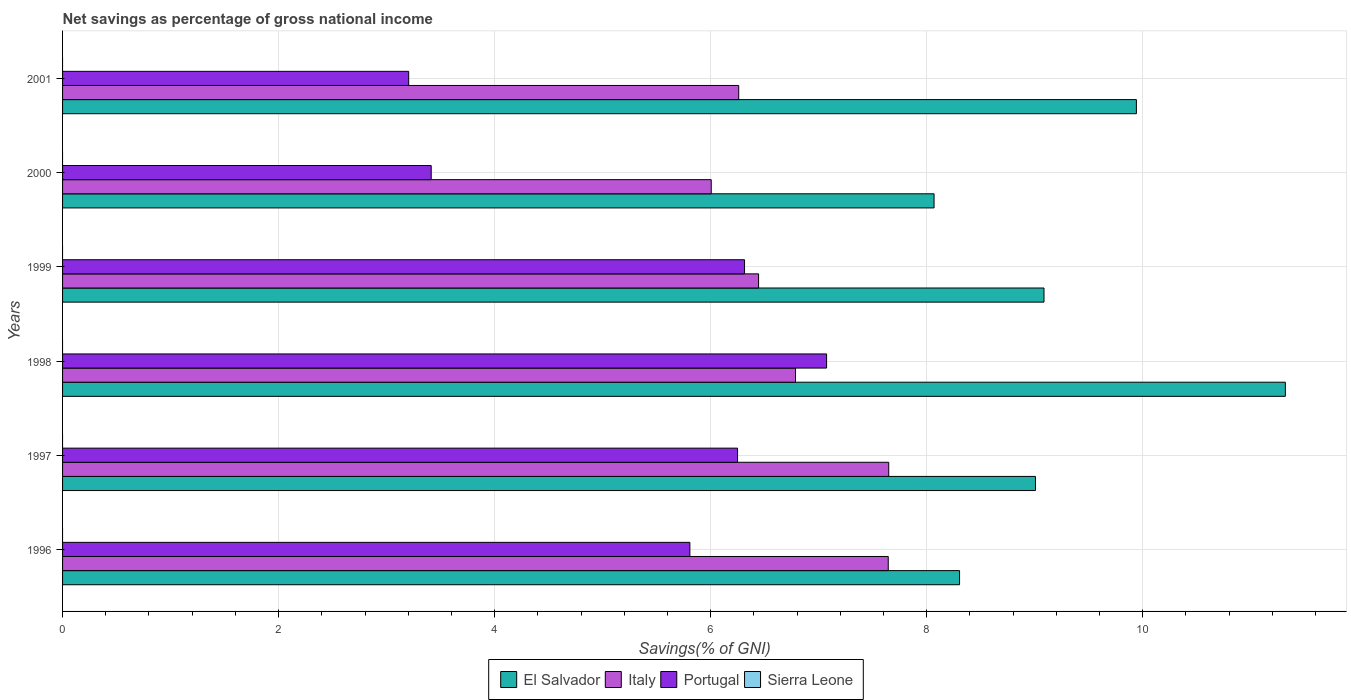How many groups of bars are there?
Offer a very short reply. 6. Are the number of bars per tick equal to the number of legend labels?
Your response must be concise. No. Are the number of bars on each tick of the Y-axis equal?
Keep it short and to the point. Yes. How many bars are there on the 3rd tick from the top?
Make the answer very short. 3. How many bars are there on the 1st tick from the bottom?
Keep it short and to the point. 3. In how many cases, is the number of bars for a given year not equal to the number of legend labels?
Offer a very short reply. 6. What is the total savings in Portugal in 1997?
Give a very brief answer. 6.25. Across all years, what is the maximum total savings in Portugal?
Ensure brevity in your answer.  7.07. Across all years, what is the minimum total savings in Italy?
Offer a terse response. 6.01. What is the total total savings in Italy in the graph?
Provide a short and direct response. 40.79. What is the difference between the total savings in El Salvador in 1997 and that in 1998?
Keep it short and to the point. -2.31. What is the difference between the total savings in Italy in 1996 and the total savings in Portugal in 2000?
Your answer should be very brief. 4.23. In the year 1996, what is the difference between the total savings in Portugal and total savings in Italy?
Your answer should be compact. -1.84. What is the ratio of the total savings in Italy in 1996 to that in 1999?
Offer a terse response. 1.19. Is the total savings in Portugal in 2000 less than that in 2001?
Keep it short and to the point. No. What is the difference between the highest and the second highest total savings in Italy?
Keep it short and to the point. 0. What is the difference between the highest and the lowest total savings in Italy?
Your answer should be compact. 1.64. Is the sum of the total savings in Portugal in 1997 and 2001 greater than the maximum total savings in Sierra Leone across all years?
Offer a terse response. Yes. Is it the case that in every year, the sum of the total savings in Italy and total savings in Portugal is greater than the sum of total savings in El Salvador and total savings in Sierra Leone?
Your response must be concise. No. Is it the case that in every year, the sum of the total savings in El Salvador and total savings in Italy is greater than the total savings in Sierra Leone?
Your answer should be compact. Yes. How many bars are there?
Your response must be concise. 18. How many years are there in the graph?
Ensure brevity in your answer.  6. What is the difference between two consecutive major ticks on the X-axis?
Provide a succinct answer. 2. How many legend labels are there?
Your answer should be very brief. 4. What is the title of the graph?
Your answer should be very brief. Net savings as percentage of gross national income. Does "Puerto Rico" appear as one of the legend labels in the graph?
Your answer should be very brief. No. What is the label or title of the X-axis?
Provide a succinct answer. Savings(% of GNI). What is the Savings(% of GNI) in El Salvador in 1996?
Your response must be concise. 8.3. What is the Savings(% of GNI) in Italy in 1996?
Your answer should be very brief. 7.64. What is the Savings(% of GNI) in Portugal in 1996?
Make the answer very short. 5.81. What is the Savings(% of GNI) of Sierra Leone in 1996?
Keep it short and to the point. 0. What is the Savings(% of GNI) of El Salvador in 1997?
Keep it short and to the point. 9.01. What is the Savings(% of GNI) in Italy in 1997?
Your answer should be compact. 7.65. What is the Savings(% of GNI) in Portugal in 1997?
Your response must be concise. 6.25. What is the Savings(% of GNI) in Sierra Leone in 1997?
Make the answer very short. 0. What is the Savings(% of GNI) of El Salvador in 1998?
Give a very brief answer. 11.32. What is the Savings(% of GNI) in Italy in 1998?
Offer a very short reply. 6.79. What is the Savings(% of GNI) in Portugal in 1998?
Give a very brief answer. 7.07. What is the Savings(% of GNI) in El Salvador in 1999?
Your answer should be very brief. 9.09. What is the Savings(% of GNI) of Italy in 1999?
Provide a short and direct response. 6.44. What is the Savings(% of GNI) of Portugal in 1999?
Your response must be concise. 6.31. What is the Savings(% of GNI) of Sierra Leone in 1999?
Your answer should be compact. 0. What is the Savings(% of GNI) of El Salvador in 2000?
Ensure brevity in your answer.  8.07. What is the Savings(% of GNI) in Italy in 2000?
Keep it short and to the point. 6.01. What is the Savings(% of GNI) of Portugal in 2000?
Your answer should be very brief. 3.41. What is the Savings(% of GNI) of Sierra Leone in 2000?
Your answer should be compact. 0. What is the Savings(% of GNI) in El Salvador in 2001?
Keep it short and to the point. 9.94. What is the Savings(% of GNI) of Italy in 2001?
Offer a terse response. 6.26. What is the Savings(% of GNI) of Portugal in 2001?
Provide a short and direct response. 3.2. What is the Savings(% of GNI) in Sierra Leone in 2001?
Make the answer very short. 0. Across all years, what is the maximum Savings(% of GNI) in El Salvador?
Ensure brevity in your answer.  11.32. Across all years, what is the maximum Savings(% of GNI) in Italy?
Your answer should be very brief. 7.65. Across all years, what is the maximum Savings(% of GNI) in Portugal?
Ensure brevity in your answer.  7.07. Across all years, what is the minimum Savings(% of GNI) in El Salvador?
Ensure brevity in your answer.  8.07. Across all years, what is the minimum Savings(% of GNI) of Italy?
Make the answer very short. 6.01. Across all years, what is the minimum Savings(% of GNI) in Portugal?
Your response must be concise. 3.2. What is the total Savings(% of GNI) of El Salvador in the graph?
Make the answer very short. 55.73. What is the total Savings(% of GNI) in Italy in the graph?
Offer a terse response. 40.79. What is the total Savings(% of GNI) in Portugal in the graph?
Offer a very short reply. 32.06. What is the difference between the Savings(% of GNI) in El Salvador in 1996 and that in 1997?
Keep it short and to the point. -0.7. What is the difference between the Savings(% of GNI) of Italy in 1996 and that in 1997?
Your answer should be compact. -0. What is the difference between the Savings(% of GNI) in Portugal in 1996 and that in 1997?
Provide a succinct answer. -0.44. What is the difference between the Savings(% of GNI) of El Salvador in 1996 and that in 1998?
Ensure brevity in your answer.  -3.02. What is the difference between the Savings(% of GNI) in Italy in 1996 and that in 1998?
Provide a short and direct response. 0.86. What is the difference between the Savings(% of GNI) of Portugal in 1996 and that in 1998?
Your response must be concise. -1.27. What is the difference between the Savings(% of GNI) in El Salvador in 1996 and that in 1999?
Your answer should be compact. -0.78. What is the difference between the Savings(% of GNI) of Italy in 1996 and that in 1999?
Your response must be concise. 1.2. What is the difference between the Savings(% of GNI) of Portugal in 1996 and that in 1999?
Offer a terse response. -0.51. What is the difference between the Savings(% of GNI) of El Salvador in 1996 and that in 2000?
Your answer should be compact. 0.24. What is the difference between the Savings(% of GNI) in Italy in 1996 and that in 2000?
Keep it short and to the point. 1.64. What is the difference between the Savings(% of GNI) in Portugal in 1996 and that in 2000?
Give a very brief answer. 2.39. What is the difference between the Savings(% of GNI) of El Salvador in 1996 and that in 2001?
Your answer should be compact. -1.64. What is the difference between the Savings(% of GNI) of Italy in 1996 and that in 2001?
Provide a succinct answer. 1.38. What is the difference between the Savings(% of GNI) of Portugal in 1996 and that in 2001?
Keep it short and to the point. 2.6. What is the difference between the Savings(% of GNI) in El Salvador in 1997 and that in 1998?
Provide a succinct answer. -2.31. What is the difference between the Savings(% of GNI) of Italy in 1997 and that in 1998?
Your response must be concise. 0.86. What is the difference between the Savings(% of GNI) of Portugal in 1997 and that in 1998?
Your answer should be very brief. -0.82. What is the difference between the Savings(% of GNI) in El Salvador in 1997 and that in 1999?
Give a very brief answer. -0.08. What is the difference between the Savings(% of GNI) of Italy in 1997 and that in 1999?
Make the answer very short. 1.21. What is the difference between the Savings(% of GNI) of Portugal in 1997 and that in 1999?
Provide a short and direct response. -0.06. What is the difference between the Savings(% of GNI) in El Salvador in 1997 and that in 2000?
Offer a very short reply. 0.94. What is the difference between the Savings(% of GNI) in Italy in 1997 and that in 2000?
Make the answer very short. 1.64. What is the difference between the Savings(% of GNI) in Portugal in 1997 and that in 2000?
Your response must be concise. 2.84. What is the difference between the Savings(% of GNI) of El Salvador in 1997 and that in 2001?
Your response must be concise. -0.93. What is the difference between the Savings(% of GNI) of Italy in 1997 and that in 2001?
Provide a short and direct response. 1.39. What is the difference between the Savings(% of GNI) of Portugal in 1997 and that in 2001?
Give a very brief answer. 3.04. What is the difference between the Savings(% of GNI) of El Salvador in 1998 and that in 1999?
Offer a very short reply. 2.23. What is the difference between the Savings(% of GNI) in Italy in 1998 and that in 1999?
Offer a terse response. 0.34. What is the difference between the Savings(% of GNI) in Portugal in 1998 and that in 1999?
Your answer should be very brief. 0.76. What is the difference between the Savings(% of GNI) of El Salvador in 1998 and that in 2000?
Make the answer very short. 3.25. What is the difference between the Savings(% of GNI) of Italy in 1998 and that in 2000?
Offer a terse response. 0.78. What is the difference between the Savings(% of GNI) of Portugal in 1998 and that in 2000?
Your answer should be compact. 3.66. What is the difference between the Savings(% of GNI) in El Salvador in 1998 and that in 2001?
Ensure brevity in your answer.  1.38. What is the difference between the Savings(% of GNI) of Italy in 1998 and that in 2001?
Ensure brevity in your answer.  0.53. What is the difference between the Savings(% of GNI) of Portugal in 1998 and that in 2001?
Give a very brief answer. 3.87. What is the difference between the Savings(% of GNI) of El Salvador in 1999 and that in 2000?
Offer a terse response. 1.02. What is the difference between the Savings(% of GNI) of Italy in 1999 and that in 2000?
Offer a very short reply. 0.44. What is the difference between the Savings(% of GNI) in Portugal in 1999 and that in 2000?
Your response must be concise. 2.9. What is the difference between the Savings(% of GNI) of El Salvador in 1999 and that in 2001?
Provide a short and direct response. -0.86. What is the difference between the Savings(% of GNI) of Italy in 1999 and that in 2001?
Your answer should be compact. 0.18. What is the difference between the Savings(% of GNI) in Portugal in 1999 and that in 2001?
Provide a succinct answer. 3.11. What is the difference between the Savings(% of GNI) in El Salvador in 2000 and that in 2001?
Provide a short and direct response. -1.87. What is the difference between the Savings(% of GNI) in Italy in 2000 and that in 2001?
Ensure brevity in your answer.  -0.25. What is the difference between the Savings(% of GNI) of Portugal in 2000 and that in 2001?
Your response must be concise. 0.21. What is the difference between the Savings(% of GNI) of El Salvador in 1996 and the Savings(% of GNI) of Italy in 1997?
Provide a short and direct response. 0.66. What is the difference between the Savings(% of GNI) in El Salvador in 1996 and the Savings(% of GNI) in Portugal in 1997?
Offer a very short reply. 2.06. What is the difference between the Savings(% of GNI) in Italy in 1996 and the Savings(% of GNI) in Portugal in 1997?
Give a very brief answer. 1.4. What is the difference between the Savings(% of GNI) of El Salvador in 1996 and the Savings(% of GNI) of Italy in 1998?
Provide a succinct answer. 1.52. What is the difference between the Savings(% of GNI) of El Salvador in 1996 and the Savings(% of GNI) of Portugal in 1998?
Make the answer very short. 1.23. What is the difference between the Savings(% of GNI) of Italy in 1996 and the Savings(% of GNI) of Portugal in 1998?
Provide a short and direct response. 0.57. What is the difference between the Savings(% of GNI) of El Salvador in 1996 and the Savings(% of GNI) of Italy in 1999?
Provide a succinct answer. 1.86. What is the difference between the Savings(% of GNI) of El Salvador in 1996 and the Savings(% of GNI) of Portugal in 1999?
Keep it short and to the point. 1.99. What is the difference between the Savings(% of GNI) of Italy in 1996 and the Savings(% of GNI) of Portugal in 1999?
Provide a succinct answer. 1.33. What is the difference between the Savings(% of GNI) in El Salvador in 1996 and the Savings(% of GNI) in Italy in 2000?
Keep it short and to the point. 2.3. What is the difference between the Savings(% of GNI) of El Salvador in 1996 and the Savings(% of GNI) of Portugal in 2000?
Provide a succinct answer. 4.89. What is the difference between the Savings(% of GNI) of Italy in 1996 and the Savings(% of GNI) of Portugal in 2000?
Make the answer very short. 4.23. What is the difference between the Savings(% of GNI) in El Salvador in 1996 and the Savings(% of GNI) in Italy in 2001?
Provide a short and direct response. 2.04. What is the difference between the Savings(% of GNI) of El Salvador in 1996 and the Savings(% of GNI) of Portugal in 2001?
Make the answer very short. 5.1. What is the difference between the Savings(% of GNI) in Italy in 1996 and the Savings(% of GNI) in Portugal in 2001?
Keep it short and to the point. 4.44. What is the difference between the Savings(% of GNI) of El Salvador in 1997 and the Savings(% of GNI) of Italy in 1998?
Your answer should be very brief. 2.22. What is the difference between the Savings(% of GNI) of El Salvador in 1997 and the Savings(% of GNI) of Portugal in 1998?
Give a very brief answer. 1.93. What is the difference between the Savings(% of GNI) in Italy in 1997 and the Savings(% of GNI) in Portugal in 1998?
Offer a terse response. 0.58. What is the difference between the Savings(% of GNI) in El Salvador in 1997 and the Savings(% of GNI) in Italy in 1999?
Give a very brief answer. 2.56. What is the difference between the Savings(% of GNI) in El Salvador in 1997 and the Savings(% of GNI) in Portugal in 1999?
Your answer should be very brief. 2.69. What is the difference between the Savings(% of GNI) in Italy in 1997 and the Savings(% of GNI) in Portugal in 1999?
Keep it short and to the point. 1.33. What is the difference between the Savings(% of GNI) of El Salvador in 1997 and the Savings(% of GNI) of Italy in 2000?
Offer a very short reply. 3. What is the difference between the Savings(% of GNI) of El Salvador in 1997 and the Savings(% of GNI) of Portugal in 2000?
Your answer should be compact. 5.59. What is the difference between the Savings(% of GNI) in Italy in 1997 and the Savings(% of GNI) in Portugal in 2000?
Provide a succinct answer. 4.24. What is the difference between the Savings(% of GNI) of El Salvador in 1997 and the Savings(% of GNI) of Italy in 2001?
Provide a short and direct response. 2.75. What is the difference between the Savings(% of GNI) of El Salvador in 1997 and the Savings(% of GNI) of Portugal in 2001?
Your response must be concise. 5.8. What is the difference between the Savings(% of GNI) in Italy in 1997 and the Savings(% of GNI) in Portugal in 2001?
Ensure brevity in your answer.  4.44. What is the difference between the Savings(% of GNI) of El Salvador in 1998 and the Savings(% of GNI) of Italy in 1999?
Offer a very short reply. 4.88. What is the difference between the Savings(% of GNI) in El Salvador in 1998 and the Savings(% of GNI) in Portugal in 1999?
Ensure brevity in your answer.  5.01. What is the difference between the Savings(% of GNI) in Italy in 1998 and the Savings(% of GNI) in Portugal in 1999?
Offer a very short reply. 0.47. What is the difference between the Savings(% of GNI) of El Salvador in 1998 and the Savings(% of GNI) of Italy in 2000?
Provide a short and direct response. 5.32. What is the difference between the Savings(% of GNI) of El Salvador in 1998 and the Savings(% of GNI) of Portugal in 2000?
Offer a very short reply. 7.91. What is the difference between the Savings(% of GNI) in Italy in 1998 and the Savings(% of GNI) in Portugal in 2000?
Offer a terse response. 3.37. What is the difference between the Savings(% of GNI) in El Salvador in 1998 and the Savings(% of GNI) in Italy in 2001?
Provide a short and direct response. 5.06. What is the difference between the Savings(% of GNI) of El Salvador in 1998 and the Savings(% of GNI) of Portugal in 2001?
Ensure brevity in your answer.  8.12. What is the difference between the Savings(% of GNI) in Italy in 1998 and the Savings(% of GNI) in Portugal in 2001?
Provide a short and direct response. 3.58. What is the difference between the Savings(% of GNI) of El Salvador in 1999 and the Savings(% of GNI) of Italy in 2000?
Your answer should be compact. 3.08. What is the difference between the Savings(% of GNI) in El Salvador in 1999 and the Savings(% of GNI) in Portugal in 2000?
Make the answer very short. 5.67. What is the difference between the Savings(% of GNI) in Italy in 1999 and the Savings(% of GNI) in Portugal in 2000?
Give a very brief answer. 3.03. What is the difference between the Savings(% of GNI) in El Salvador in 1999 and the Savings(% of GNI) in Italy in 2001?
Your answer should be very brief. 2.83. What is the difference between the Savings(% of GNI) of El Salvador in 1999 and the Savings(% of GNI) of Portugal in 2001?
Your answer should be very brief. 5.88. What is the difference between the Savings(% of GNI) of Italy in 1999 and the Savings(% of GNI) of Portugal in 2001?
Your answer should be compact. 3.24. What is the difference between the Savings(% of GNI) in El Salvador in 2000 and the Savings(% of GNI) in Italy in 2001?
Your response must be concise. 1.81. What is the difference between the Savings(% of GNI) of El Salvador in 2000 and the Savings(% of GNI) of Portugal in 2001?
Your answer should be compact. 4.86. What is the difference between the Savings(% of GNI) of Italy in 2000 and the Savings(% of GNI) of Portugal in 2001?
Your response must be concise. 2.8. What is the average Savings(% of GNI) of El Salvador per year?
Give a very brief answer. 9.29. What is the average Savings(% of GNI) of Italy per year?
Provide a short and direct response. 6.8. What is the average Savings(% of GNI) of Portugal per year?
Ensure brevity in your answer.  5.34. What is the average Savings(% of GNI) of Sierra Leone per year?
Provide a succinct answer. 0. In the year 1996, what is the difference between the Savings(% of GNI) of El Salvador and Savings(% of GNI) of Italy?
Make the answer very short. 0.66. In the year 1996, what is the difference between the Savings(% of GNI) of El Salvador and Savings(% of GNI) of Portugal?
Offer a very short reply. 2.5. In the year 1996, what is the difference between the Savings(% of GNI) in Italy and Savings(% of GNI) in Portugal?
Ensure brevity in your answer.  1.84. In the year 1997, what is the difference between the Savings(% of GNI) in El Salvador and Savings(% of GNI) in Italy?
Give a very brief answer. 1.36. In the year 1997, what is the difference between the Savings(% of GNI) of El Salvador and Savings(% of GNI) of Portugal?
Provide a succinct answer. 2.76. In the year 1997, what is the difference between the Savings(% of GNI) of Italy and Savings(% of GNI) of Portugal?
Give a very brief answer. 1.4. In the year 1998, what is the difference between the Savings(% of GNI) in El Salvador and Savings(% of GNI) in Italy?
Make the answer very short. 4.53. In the year 1998, what is the difference between the Savings(% of GNI) of El Salvador and Savings(% of GNI) of Portugal?
Offer a terse response. 4.25. In the year 1998, what is the difference between the Savings(% of GNI) in Italy and Savings(% of GNI) in Portugal?
Your answer should be very brief. -0.29. In the year 1999, what is the difference between the Savings(% of GNI) in El Salvador and Savings(% of GNI) in Italy?
Provide a short and direct response. 2.64. In the year 1999, what is the difference between the Savings(% of GNI) in El Salvador and Savings(% of GNI) in Portugal?
Keep it short and to the point. 2.77. In the year 1999, what is the difference between the Savings(% of GNI) in Italy and Savings(% of GNI) in Portugal?
Give a very brief answer. 0.13. In the year 2000, what is the difference between the Savings(% of GNI) of El Salvador and Savings(% of GNI) of Italy?
Give a very brief answer. 2.06. In the year 2000, what is the difference between the Savings(% of GNI) in El Salvador and Savings(% of GNI) in Portugal?
Ensure brevity in your answer.  4.66. In the year 2000, what is the difference between the Savings(% of GNI) in Italy and Savings(% of GNI) in Portugal?
Ensure brevity in your answer.  2.59. In the year 2001, what is the difference between the Savings(% of GNI) of El Salvador and Savings(% of GNI) of Italy?
Your answer should be compact. 3.68. In the year 2001, what is the difference between the Savings(% of GNI) of El Salvador and Savings(% of GNI) of Portugal?
Offer a very short reply. 6.74. In the year 2001, what is the difference between the Savings(% of GNI) in Italy and Savings(% of GNI) in Portugal?
Keep it short and to the point. 3.06. What is the ratio of the Savings(% of GNI) in El Salvador in 1996 to that in 1997?
Your response must be concise. 0.92. What is the ratio of the Savings(% of GNI) in Italy in 1996 to that in 1997?
Make the answer very short. 1. What is the ratio of the Savings(% of GNI) in Portugal in 1996 to that in 1997?
Provide a short and direct response. 0.93. What is the ratio of the Savings(% of GNI) in El Salvador in 1996 to that in 1998?
Your answer should be compact. 0.73. What is the ratio of the Savings(% of GNI) of Italy in 1996 to that in 1998?
Give a very brief answer. 1.13. What is the ratio of the Savings(% of GNI) of Portugal in 1996 to that in 1998?
Keep it short and to the point. 0.82. What is the ratio of the Savings(% of GNI) in El Salvador in 1996 to that in 1999?
Your answer should be compact. 0.91. What is the ratio of the Savings(% of GNI) of Italy in 1996 to that in 1999?
Provide a short and direct response. 1.19. What is the ratio of the Savings(% of GNI) of Portugal in 1996 to that in 1999?
Your response must be concise. 0.92. What is the ratio of the Savings(% of GNI) in El Salvador in 1996 to that in 2000?
Your answer should be compact. 1.03. What is the ratio of the Savings(% of GNI) in Italy in 1996 to that in 2000?
Your answer should be compact. 1.27. What is the ratio of the Savings(% of GNI) in Portugal in 1996 to that in 2000?
Provide a succinct answer. 1.7. What is the ratio of the Savings(% of GNI) of El Salvador in 1996 to that in 2001?
Your answer should be very brief. 0.84. What is the ratio of the Savings(% of GNI) of Italy in 1996 to that in 2001?
Make the answer very short. 1.22. What is the ratio of the Savings(% of GNI) of Portugal in 1996 to that in 2001?
Give a very brief answer. 1.81. What is the ratio of the Savings(% of GNI) in El Salvador in 1997 to that in 1998?
Provide a short and direct response. 0.8. What is the ratio of the Savings(% of GNI) of Italy in 1997 to that in 1998?
Give a very brief answer. 1.13. What is the ratio of the Savings(% of GNI) of Portugal in 1997 to that in 1998?
Offer a very short reply. 0.88. What is the ratio of the Savings(% of GNI) of El Salvador in 1997 to that in 1999?
Provide a short and direct response. 0.99. What is the ratio of the Savings(% of GNI) of Italy in 1997 to that in 1999?
Keep it short and to the point. 1.19. What is the ratio of the Savings(% of GNI) in Portugal in 1997 to that in 1999?
Your answer should be very brief. 0.99. What is the ratio of the Savings(% of GNI) in El Salvador in 1997 to that in 2000?
Give a very brief answer. 1.12. What is the ratio of the Savings(% of GNI) in Italy in 1997 to that in 2000?
Give a very brief answer. 1.27. What is the ratio of the Savings(% of GNI) of Portugal in 1997 to that in 2000?
Your answer should be very brief. 1.83. What is the ratio of the Savings(% of GNI) of El Salvador in 1997 to that in 2001?
Offer a terse response. 0.91. What is the ratio of the Savings(% of GNI) of Italy in 1997 to that in 2001?
Offer a terse response. 1.22. What is the ratio of the Savings(% of GNI) of Portugal in 1997 to that in 2001?
Keep it short and to the point. 1.95. What is the ratio of the Savings(% of GNI) of El Salvador in 1998 to that in 1999?
Give a very brief answer. 1.25. What is the ratio of the Savings(% of GNI) in Italy in 1998 to that in 1999?
Your answer should be compact. 1.05. What is the ratio of the Savings(% of GNI) in Portugal in 1998 to that in 1999?
Your answer should be very brief. 1.12. What is the ratio of the Savings(% of GNI) in El Salvador in 1998 to that in 2000?
Provide a short and direct response. 1.4. What is the ratio of the Savings(% of GNI) in Italy in 1998 to that in 2000?
Provide a succinct answer. 1.13. What is the ratio of the Savings(% of GNI) of Portugal in 1998 to that in 2000?
Give a very brief answer. 2.07. What is the ratio of the Savings(% of GNI) in El Salvador in 1998 to that in 2001?
Give a very brief answer. 1.14. What is the ratio of the Savings(% of GNI) of Italy in 1998 to that in 2001?
Give a very brief answer. 1.08. What is the ratio of the Savings(% of GNI) of Portugal in 1998 to that in 2001?
Make the answer very short. 2.21. What is the ratio of the Savings(% of GNI) in El Salvador in 1999 to that in 2000?
Ensure brevity in your answer.  1.13. What is the ratio of the Savings(% of GNI) of Italy in 1999 to that in 2000?
Your response must be concise. 1.07. What is the ratio of the Savings(% of GNI) of Portugal in 1999 to that in 2000?
Provide a succinct answer. 1.85. What is the ratio of the Savings(% of GNI) of El Salvador in 1999 to that in 2001?
Your response must be concise. 0.91. What is the ratio of the Savings(% of GNI) of Italy in 1999 to that in 2001?
Ensure brevity in your answer.  1.03. What is the ratio of the Savings(% of GNI) in Portugal in 1999 to that in 2001?
Offer a terse response. 1.97. What is the ratio of the Savings(% of GNI) in El Salvador in 2000 to that in 2001?
Give a very brief answer. 0.81. What is the ratio of the Savings(% of GNI) of Italy in 2000 to that in 2001?
Your answer should be compact. 0.96. What is the ratio of the Savings(% of GNI) in Portugal in 2000 to that in 2001?
Your answer should be very brief. 1.06. What is the difference between the highest and the second highest Savings(% of GNI) of El Salvador?
Your answer should be compact. 1.38. What is the difference between the highest and the second highest Savings(% of GNI) in Italy?
Offer a terse response. 0. What is the difference between the highest and the second highest Savings(% of GNI) in Portugal?
Provide a succinct answer. 0.76. What is the difference between the highest and the lowest Savings(% of GNI) in El Salvador?
Keep it short and to the point. 3.25. What is the difference between the highest and the lowest Savings(% of GNI) of Italy?
Your answer should be compact. 1.64. What is the difference between the highest and the lowest Savings(% of GNI) in Portugal?
Make the answer very short. 3.87. 